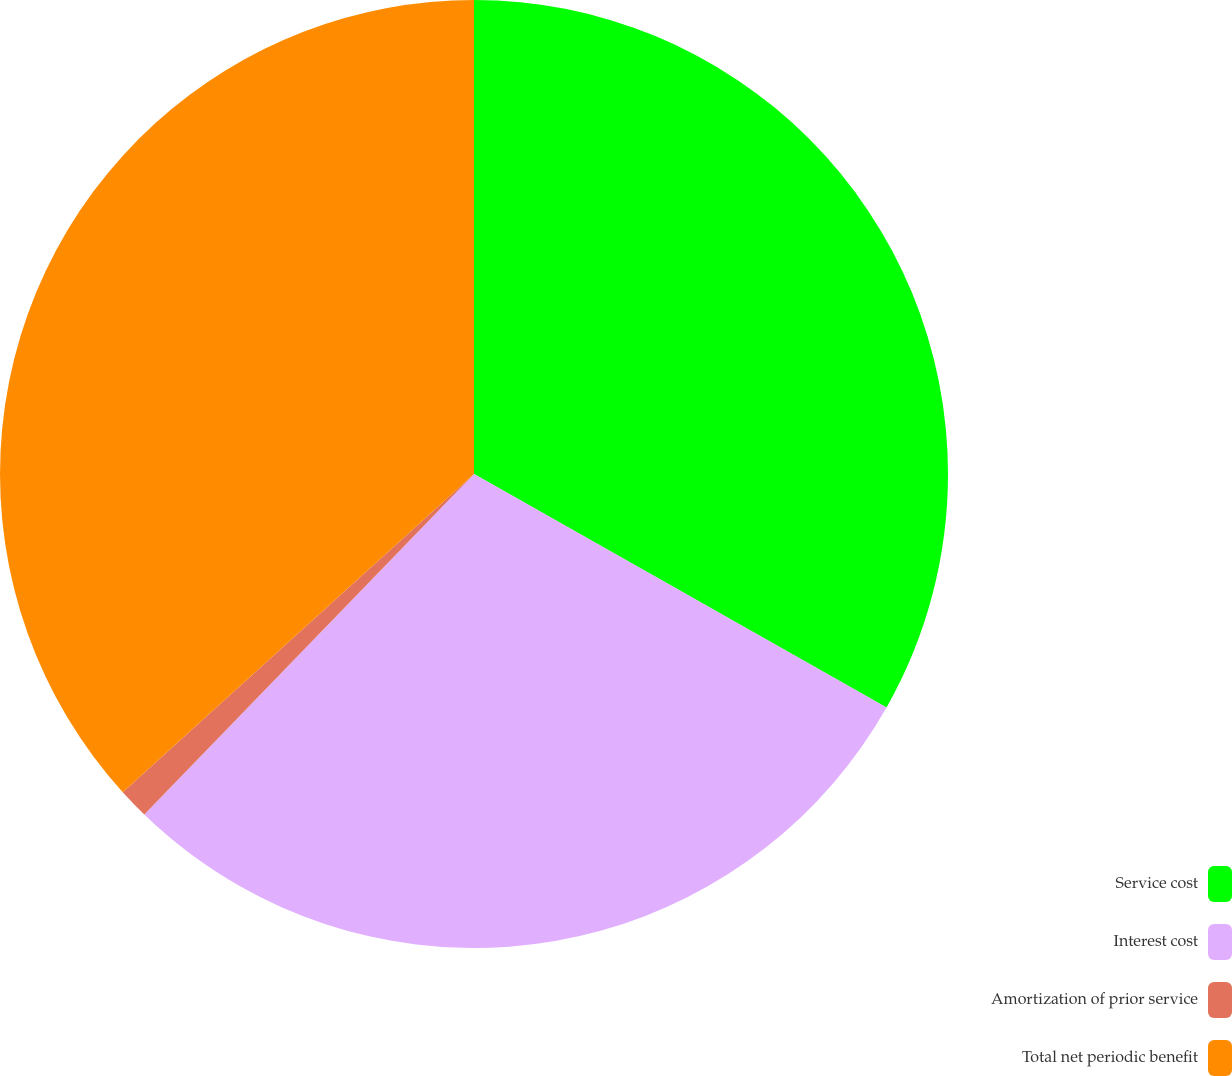Convert chart to OTSL. <chart><loc_0><loc_0><loc_500><loc_500><pie_chart><fcel>Service cost<fcel>Interest cost<fcel>Amortization of prior service<fcel>Total net periodic benefit<nl><fcel>33.2%<fcel>29.05%<fcel>1.04%<fcel>36.72%<nl></chart> 